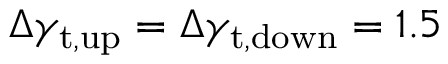Convert formula to latex. <formula><loc_0><loc_0><loc_500><loc_500>\Delta \gamma _ { t , u p } = \Delta \gamma _ { t , d o w n } = 1 . 5</formula> 